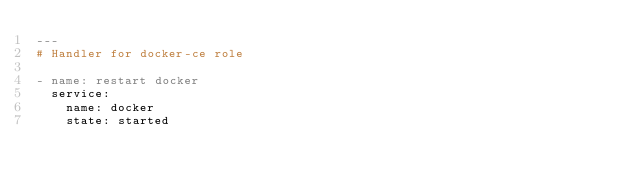<code> <loc_0><loc_0><loc_500><loc_500><_YAML_>---
# Handler for docker-ce role

- name: restart docker 
  service: 
    name: docker
    state: started</code> 